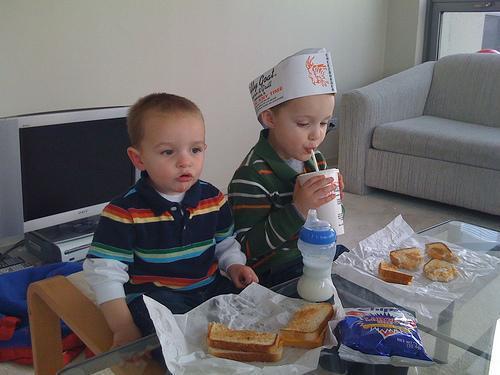How many children are there?
Give a very brief answer. 2. How many pieces of sandwich are there?
Give a very brief answer. 4. How many couches can be seen?
Give a very brief answer. 1. How many people can you see?
Give a very brief answer. 2. How many cats are in the photo?
Give a very brief answer. 0. 